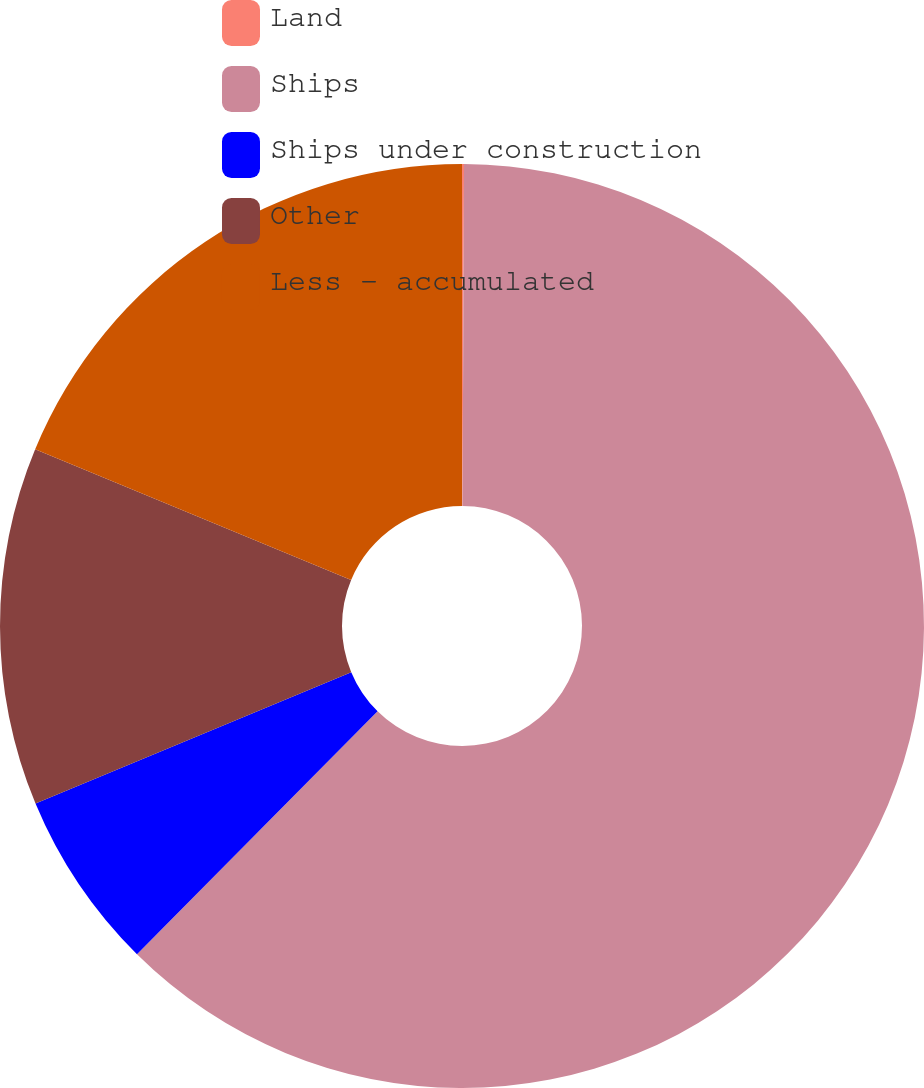Convert chart. <chart><loc_0><loc_0><loc_500><loc_500><pie_chart><fcel>Land<fcel>Ships<fcel>Ships under construction<fcel>Other<fcel>Less - accumulated<nl><fcel>0.07%<fcel>62.35%<fcel>6.3%<fcel>12.53%<fcel>18.75%<nl></chart> 